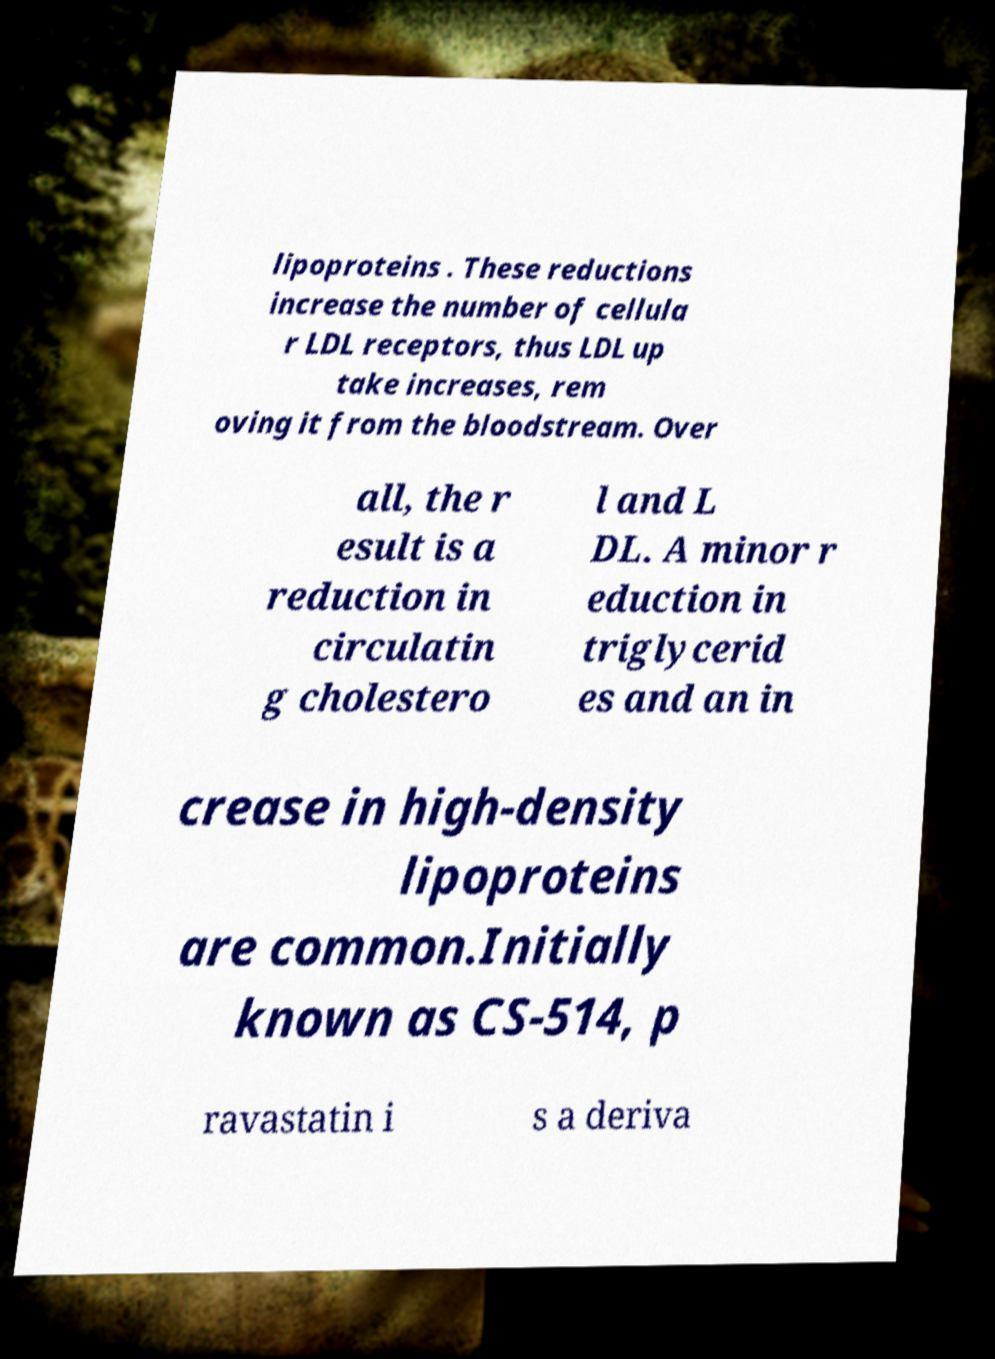Please read and relay the text visible in this image. What does it say? lipoproteins . These reductions increase the number of cellula r LDL receptors, thus LDL up take increases, rem oving it from the bloodstream. Over all, the r esult is a reduction in circulatin g cholestero l and L DL. A minor r eduction in triglycerid es and an in crease in high-density lipoproteins are common.Initially known as CS-514, p ravastatin i s a deriva 